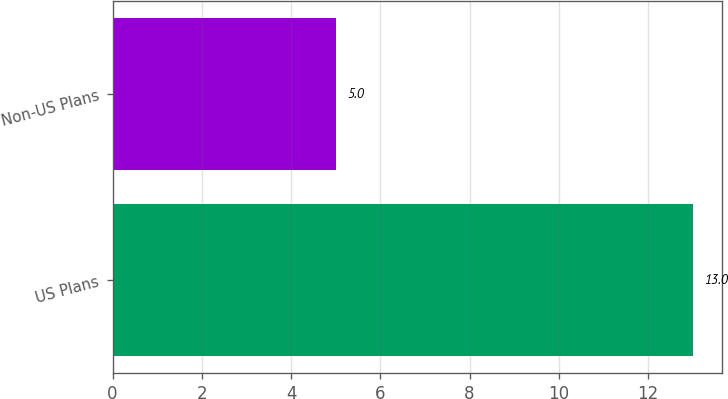<chart> <loc_0><loc_0><loc_500><loc_500><bar_chart><fcel>US Plans<fcel>Non-US Plans<nl><fcel>13<fcel>5<nl></chart> 